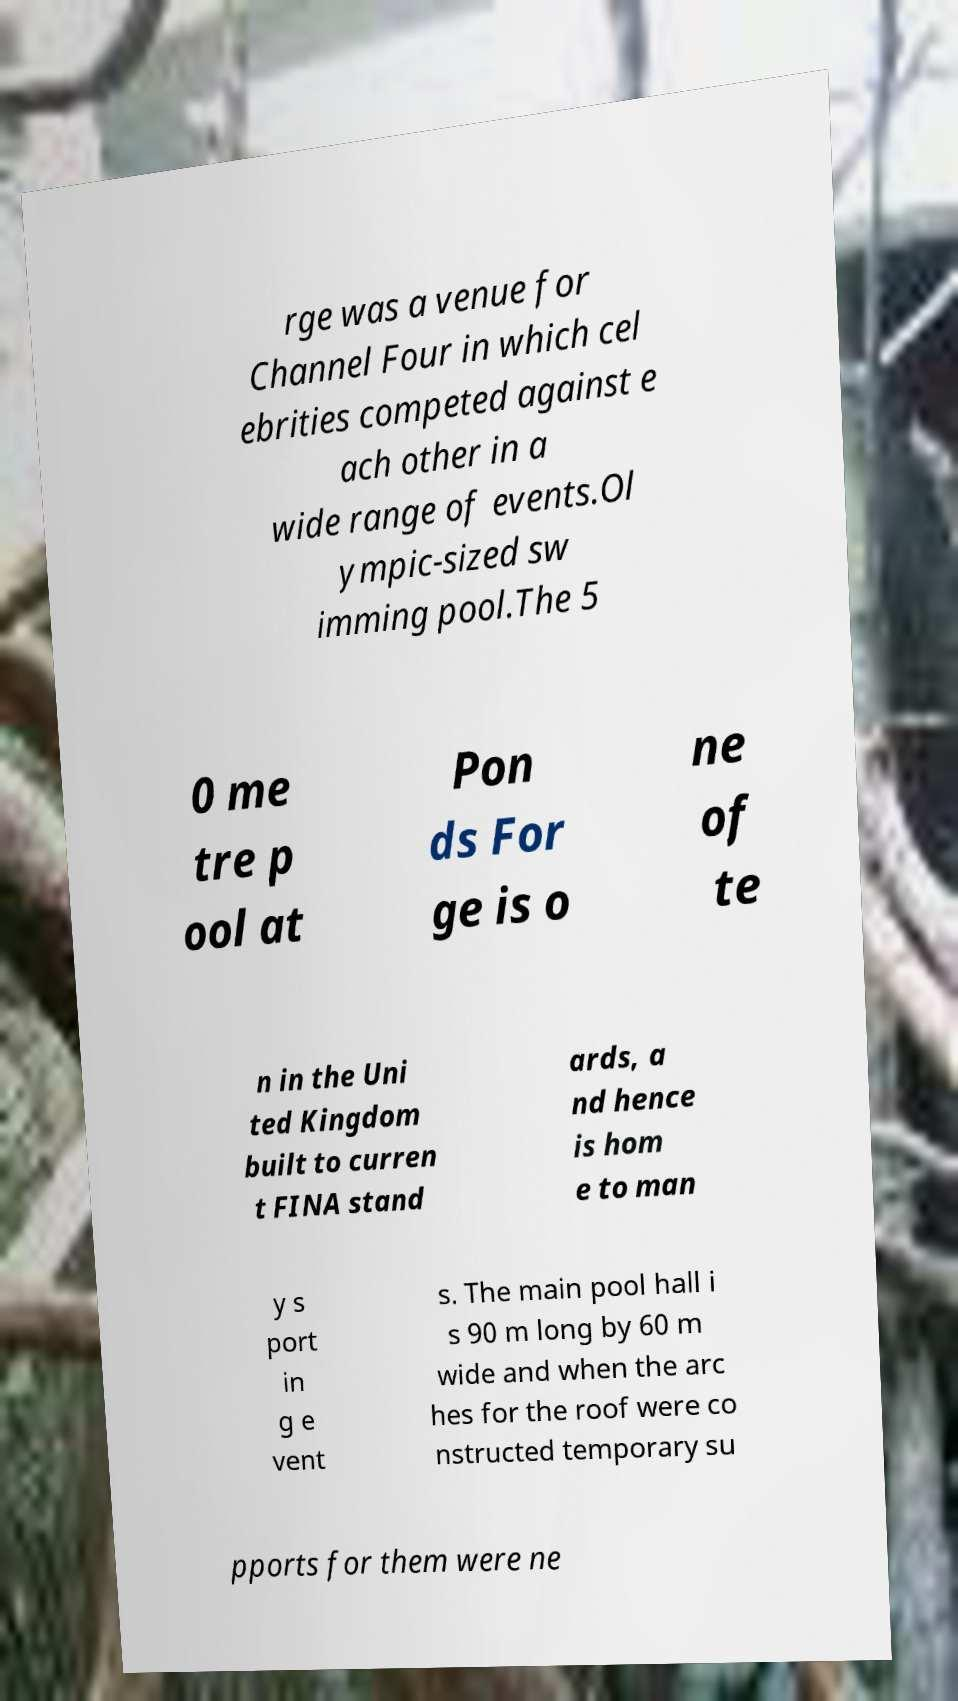There's text embedded in this image that I need extracted. Can you transcribe it verbatim? rge was a venue for Channel Four in which cel ebrities competed against e ach other in a wide range of events.Ol ympic-sized sw imming pool.The 5 0 me tre p ool at Pon ds For ge is o ne of te n in the Uni ted Kingdom built to curren t FINA stand ards, a nd hence is hom e to man y s port in g e vent s. The main pool hall i s 90 m long by 60 m wide and when the arc hes for the roof were co nstructed temporary su pports for them were ne 